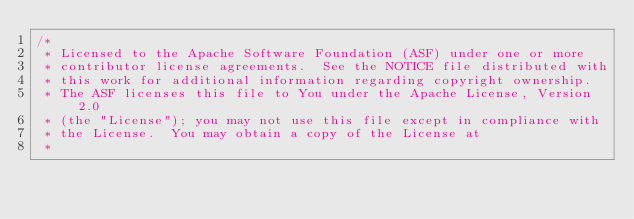Convert code to text. <code><loc_0><loc_0><loc_500><loc_500><_Java_>/*
 * Licensed to the Apache Software Foundation (ASF) under one or more
 * contributor license agreements.  See the NOTICE file distributed with
 * this work for additional information regarding copyright ownership.
 * The ASF licenses this file to You under the Apache License, Version 2.0
 * (the "License"); you may not use this file except in compliance with
 * the License.  You may obtain a copy of the License at
 *</code> 